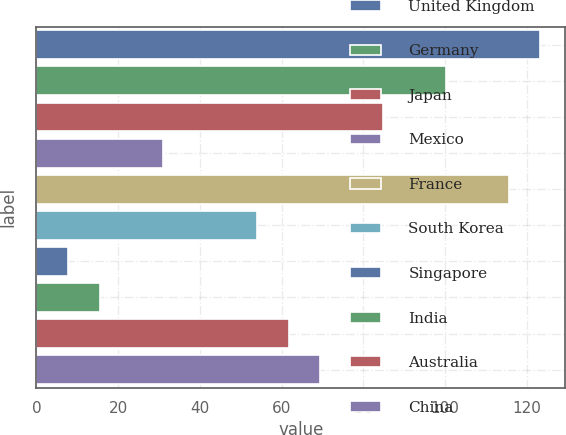Convert chart to OTSL. <chart><loc_0><loc_0><loc_500><loc_500><bar_chart><fcel>United Kingdom<fcel>Germany<fcel>Japan<fcel>Mexico<fcel>France<fcel>South Korea<fcel>Singapore<fcel>India<fcel>Australia<fcel>China<nl><fcel>123.3<fcel>100.2<fcel>84.8<fcel>30.9<fcel>115.6<fcel>54<fcel>7.8<fcel>15.5<fcel>61.7<fcel>69.4<nl></chart> 